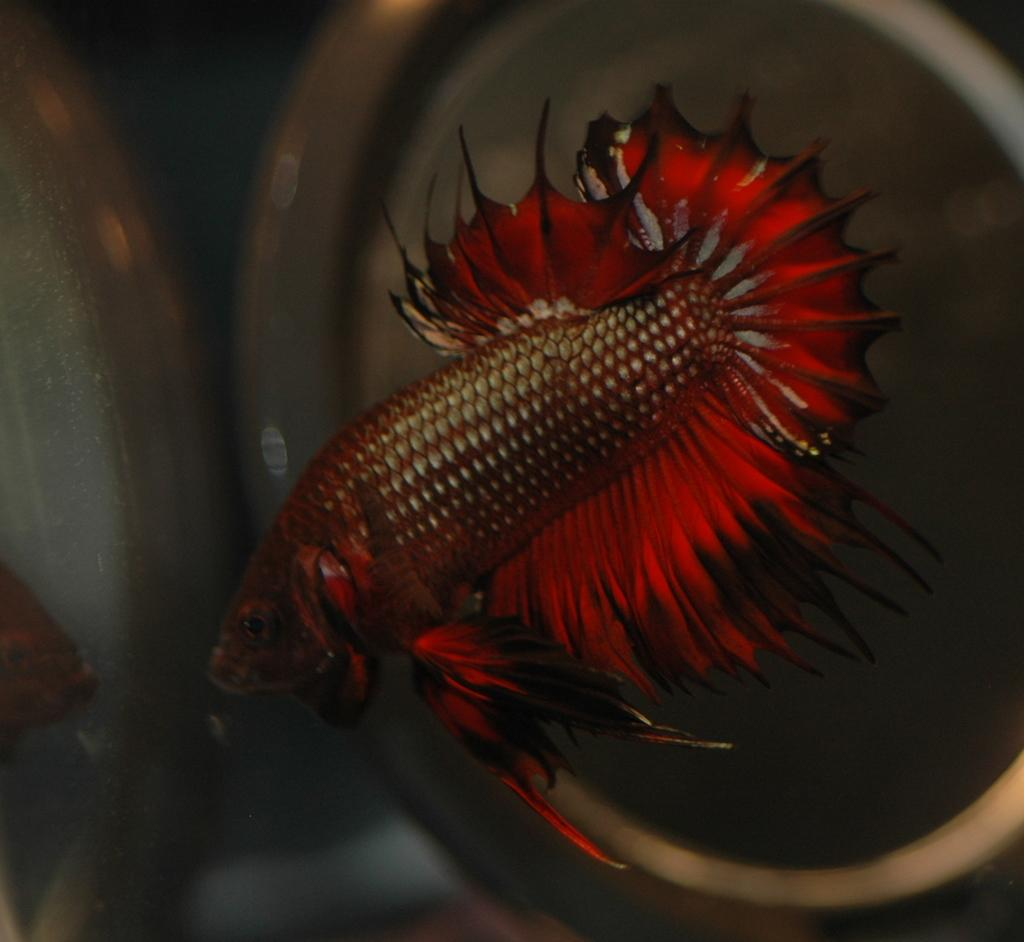What type of animal is in the image? There is a red fish in the image. What can be seen in the background of the image? There is an object in the background of the image, and the background is dark. What else is visible in the image besides the fish? The reflection of a fish and the reflection of an object are visible in the image. How many rings are being exchanged by the minister and the worm in the image? There is no minister or worm present in the image, so no rings are being exchanged. 